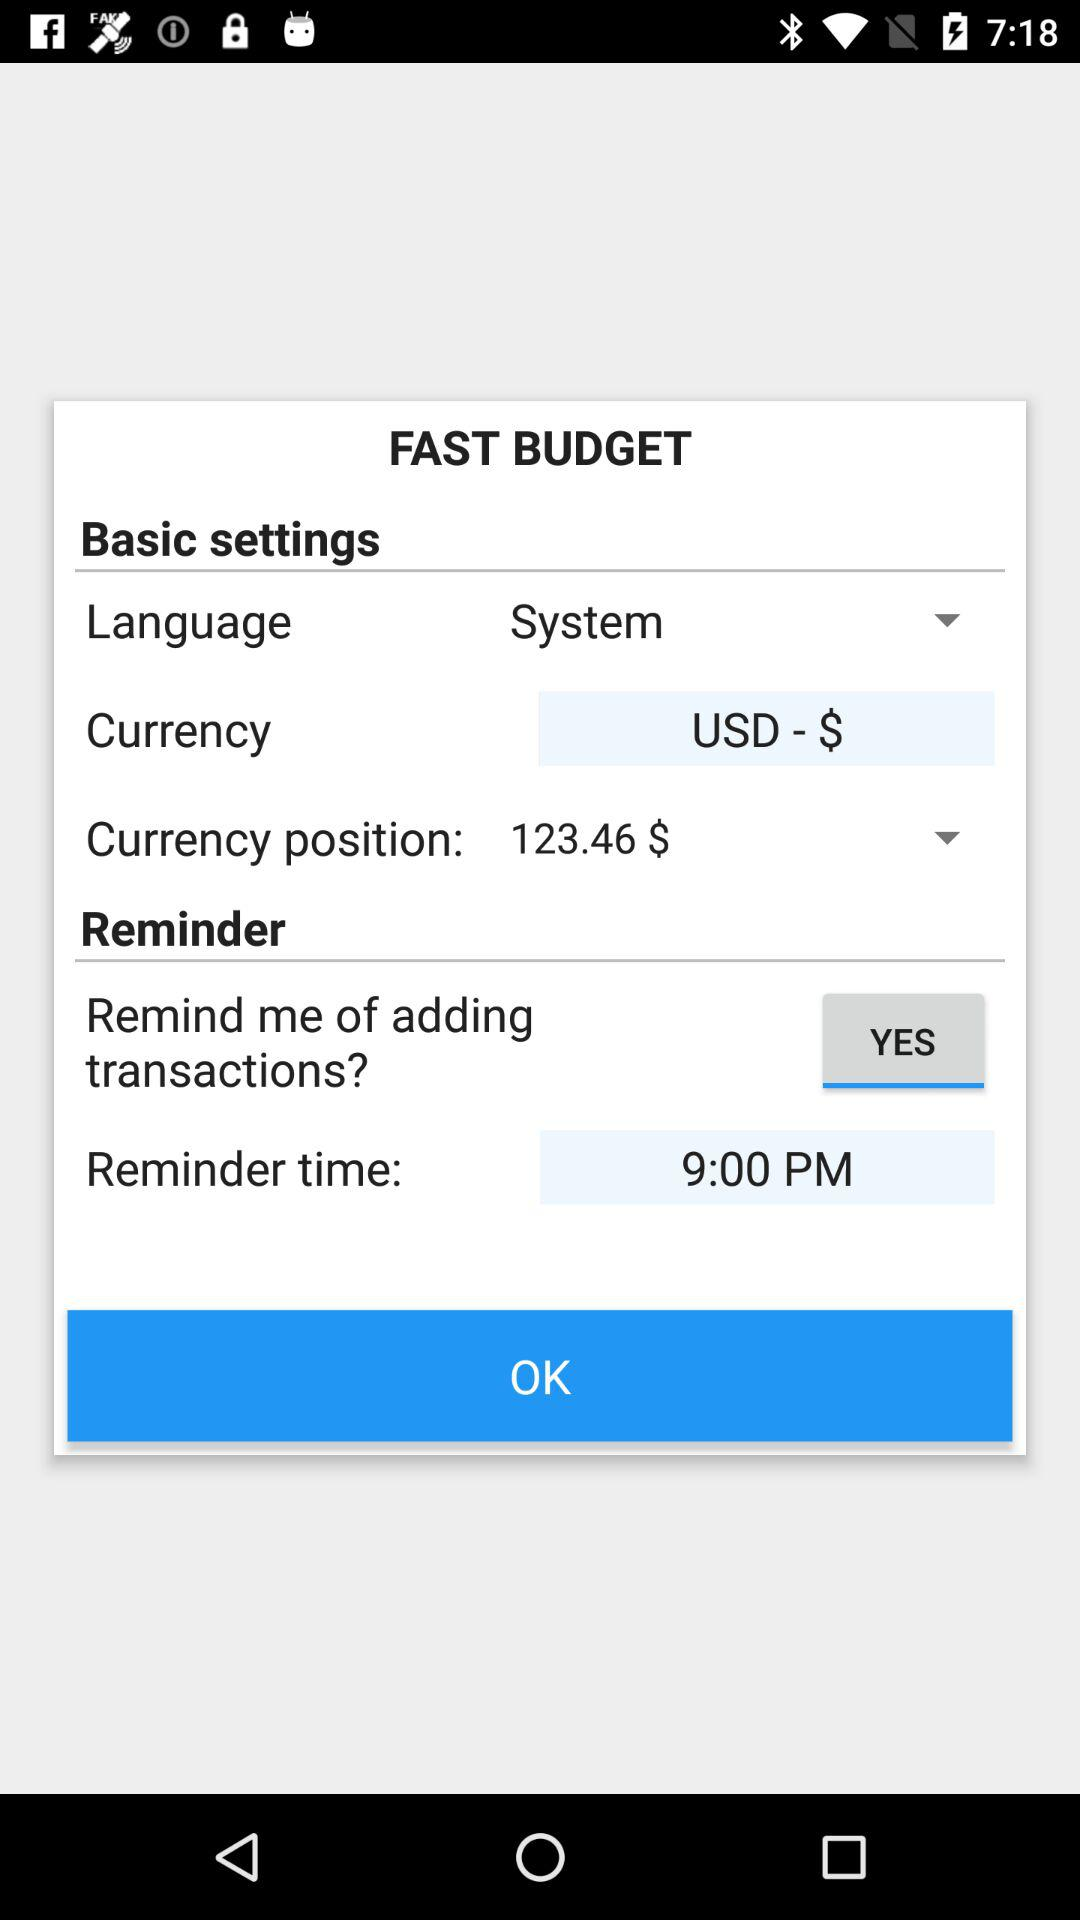What is the currency position? The currency position is $123.46. 